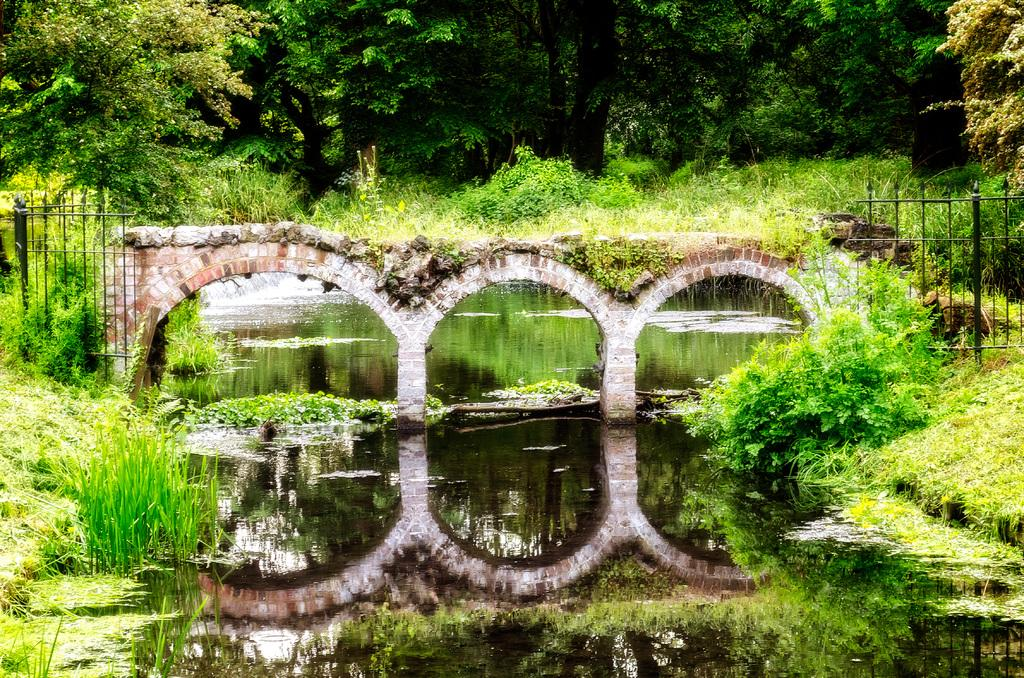What type of structure can be seen in the image? There is a bridge in the image. What type of vegetation is present in the image? There are plants, trees, and grass in the image. What type of barrier can be seen in the image? There is fencing in the image. What can be seen reflecting on the water in the image? There are reflections on the water in the image. What type of wine is being served on the island in the image? There is no island or wine present in the image. What type of paper is being used to write on in the image? There is no paper or writing activity present in the image. 